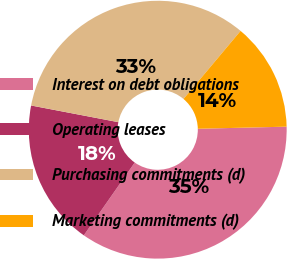<chart> <loc_0><loc_0><loc_500><loc_500><pie_chart><fcel>Interest on debt obligations<fcel>Operating leases<fcel>Purchasing commitments (d)<fcel>Marketing commitments (d)<nl><fcel>35.09%<fcel>18.29%<fcel>33.1%<fcel>13.52%<nl></chart> 